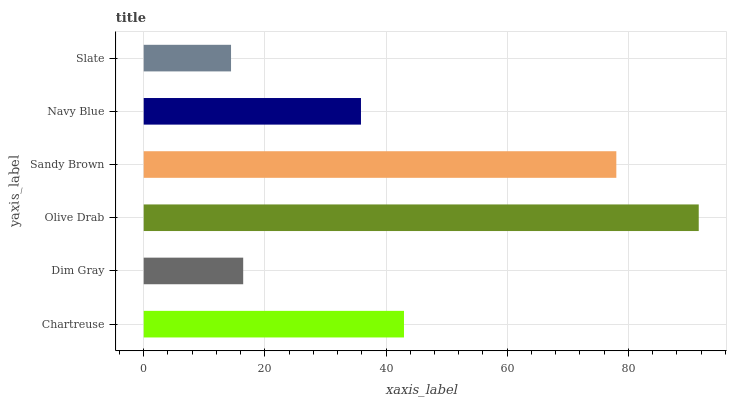Is Slate the minimum?
Answer yes or no. Yes. Is Olive Drab the maximum?
Answer yes or no. Yes. Is Dim Gray the minimum?
Answer yes or no. No. Is Dim Gray the maximum?
Answer yes or no. No. Is Chartreuse greater than Dim Gray?
Answer yes or no. Yes. Is Dim Gray less than Chartreuse?
Answer yes or no. Yes. Is Dim Gray greater than Chartreuse?
Answer yes or no. No. Is Chartreuse less than Dim Gray?
Answer yes or no. No. Is Chartreuse the high median?
Answer yes or no. Yes. Is Navy Blue the low median?
Answer yes or no. Yes. Is Olive Drab the high median?
Answer yes or no. No. Is Sandy Brown the low median?
Answer yes or no. No. 